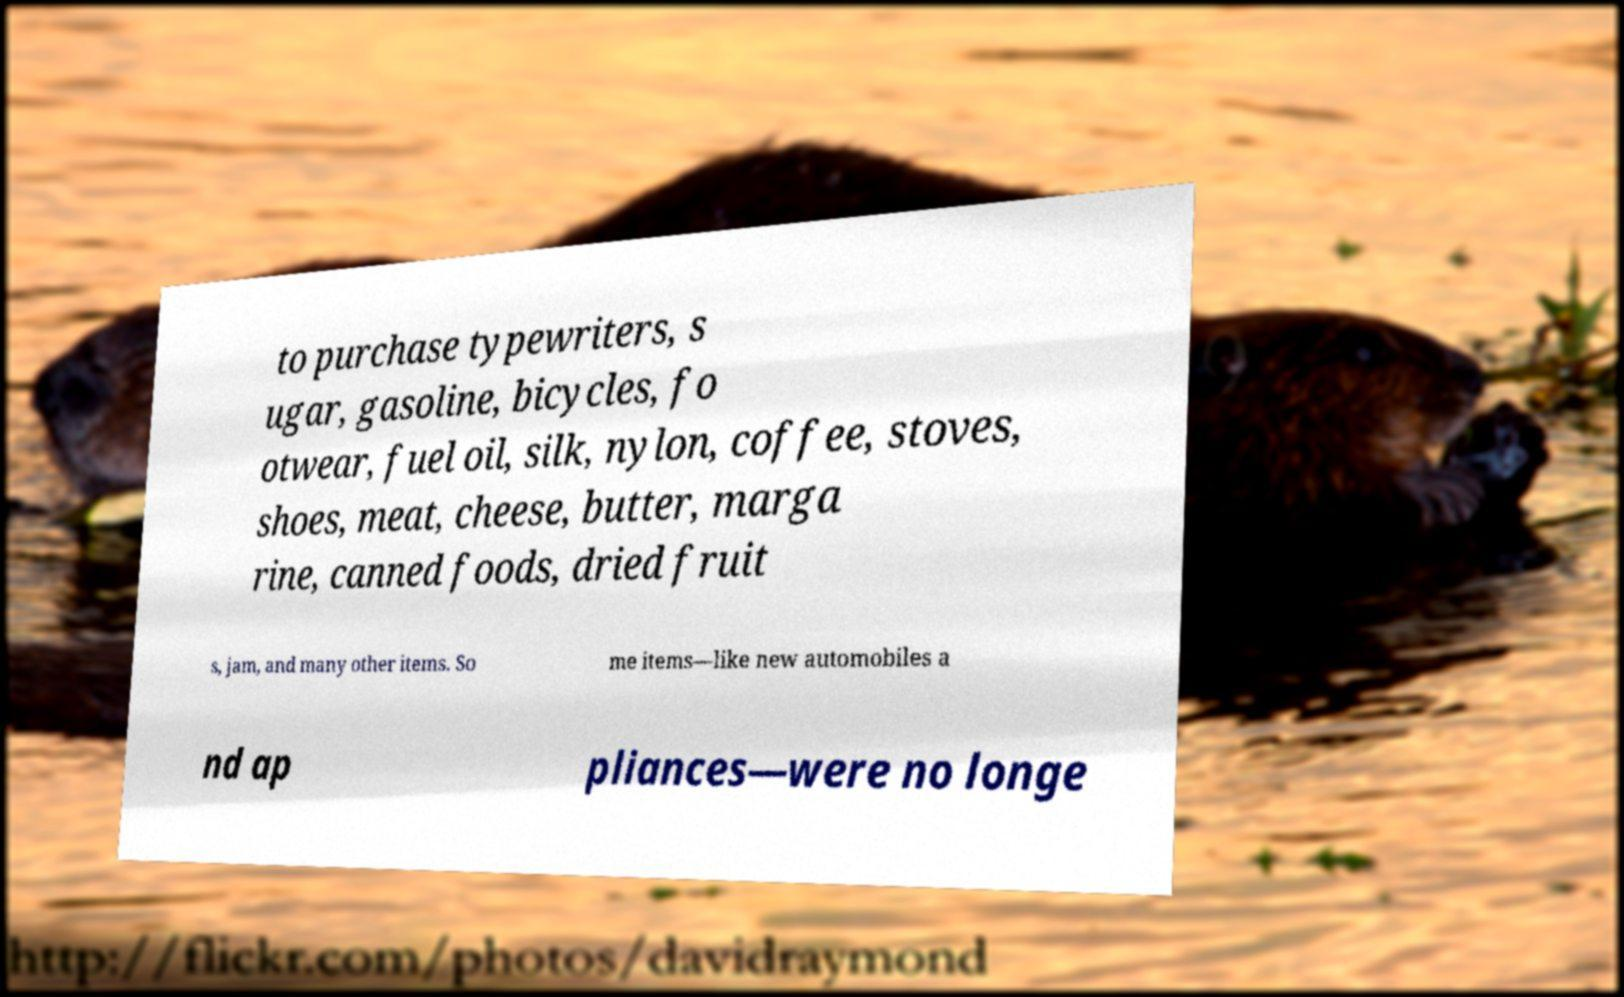For documentation purposes, I need the text within this image transcribed. Could you provide that? to purchase typewriters, s ugar, gasoline, bicycles, fo otwear, fuel oil, silk, nylon, coffee, stoves, shoes, meat, cheese, butter, marga rine, canned foods, dried fruit s, jam, and many other items. So me items—like new automobiles a nd ap pliances—were no longe 